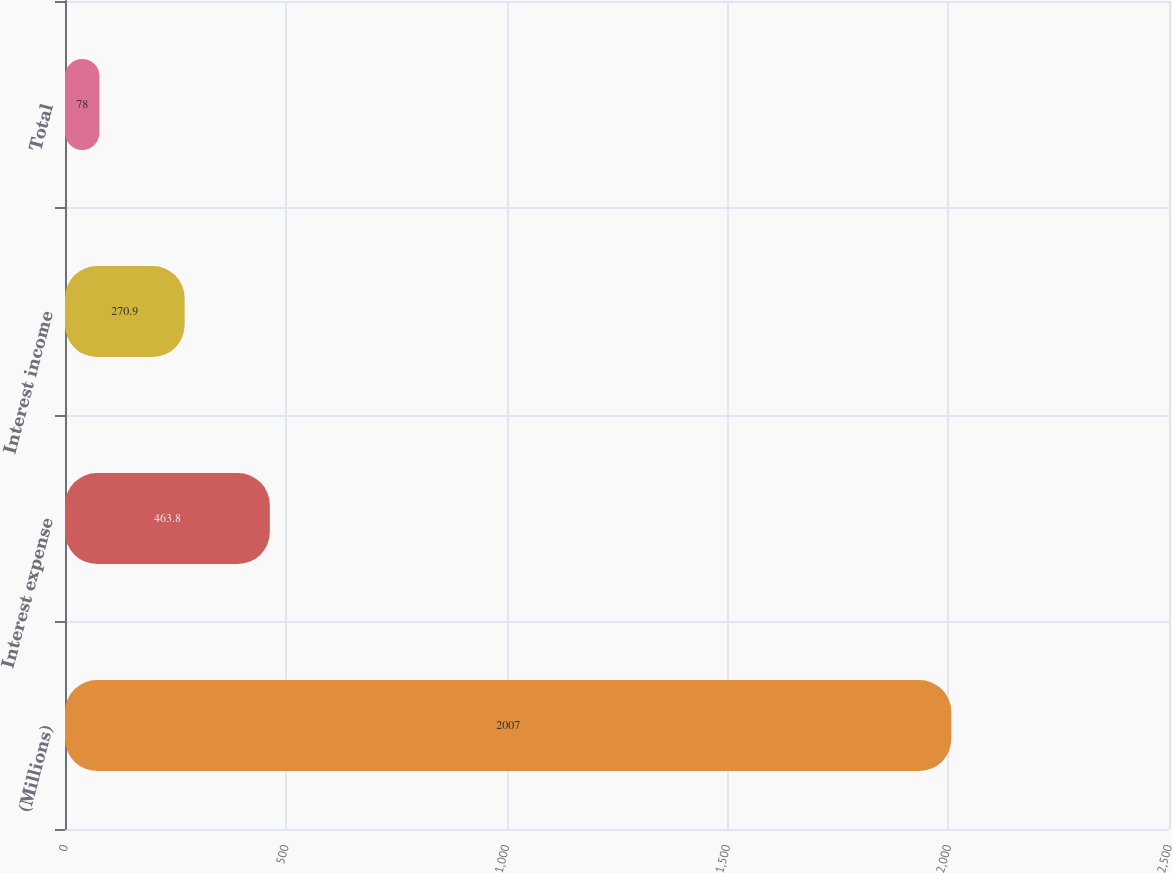<chart> <loc_0><loc_0><loc_500><loc_500><bar_chart><fcel>(Millions)<fcel>Interest expense<fcel>Interest income<fcel>Total<nl><fcel>2007<fcel>463.8<fcel>270.9<fcel>78<nl></chart> 